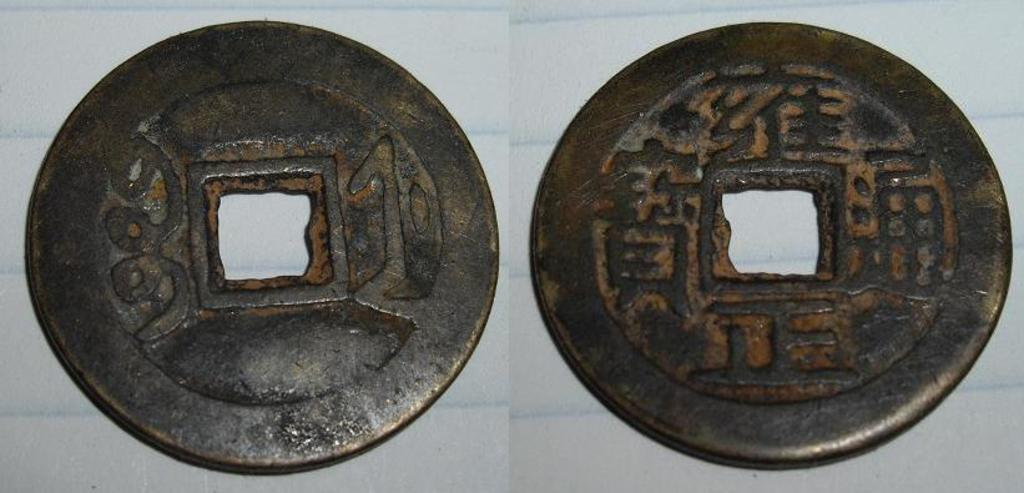What are the main objects in the image? There are two circular shaped metal objects in the image. What is the color of the surface on which the objects are placed? The objects are on a white surface. How does the bit help in transporting the objects in the image? There is no mention of a bit in the image, and the objects are stationary on the white surface. 